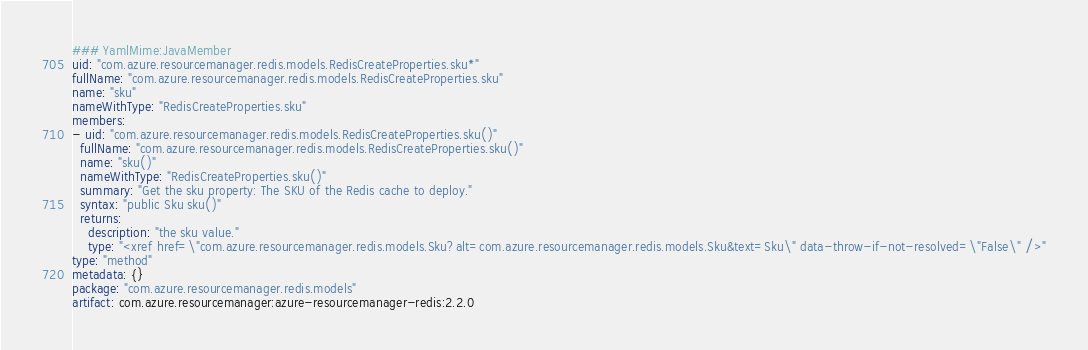Convert code to text. <code><loc_0><loc_0><loc_500><loc_500><_YAML_>### YamlMime:JavaMember
uid: "com.azure.resourcemanager.redis.models.RedisCreateProperties.sku*"
fullName: "com.azure.resourcemanager.redis.models.RedisCreateProperties.sku"
name: "sku"
nameWithType: "RedisCreateProperties.sku"
members:
- uid: "com.azure.resourcemanager.redis.models.RedisCreateProperties.sku()"
  fullName: "com.azure.resourcemanager.redis.models.RedisCreateProperties.sku()"
  name: "sku()"
  nameWithType: "RedisCreateProperties.sku()"
  summary: "Get the sku property: The SKU of the Redis cache to deploy."
  syntax: "public Sku sku()"
  returns:
    description: "the sku value."
    type: "<xref href=\"com.azure.resourcemanager.redis.models.Sku?alt=com.azure.resourcemanager.redis.models.Sku&text=Sku\" data-throw-if-not-resolved=\"False\" />"
type: "method"
metadata: {}
package: "com.azure.resourcemanager.redis.models"
artifact: com.azure.resourcemanager:azure-resourcemanager-redis:2.2.0
</code> 